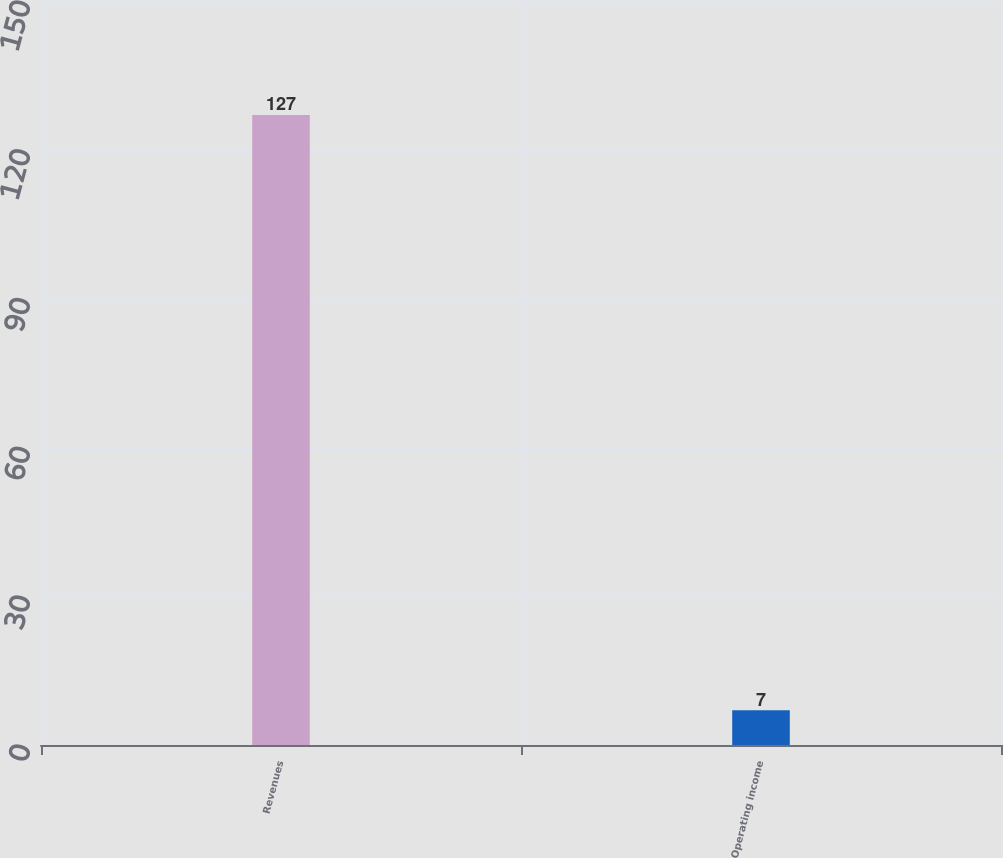Convert chart. <chart><loc_0><loc_0><loc_500><loc_500><bar_chart><fcel>Revenues<fcel>Operating income<nl><fcel>127<fcel>7<nl></chart> 